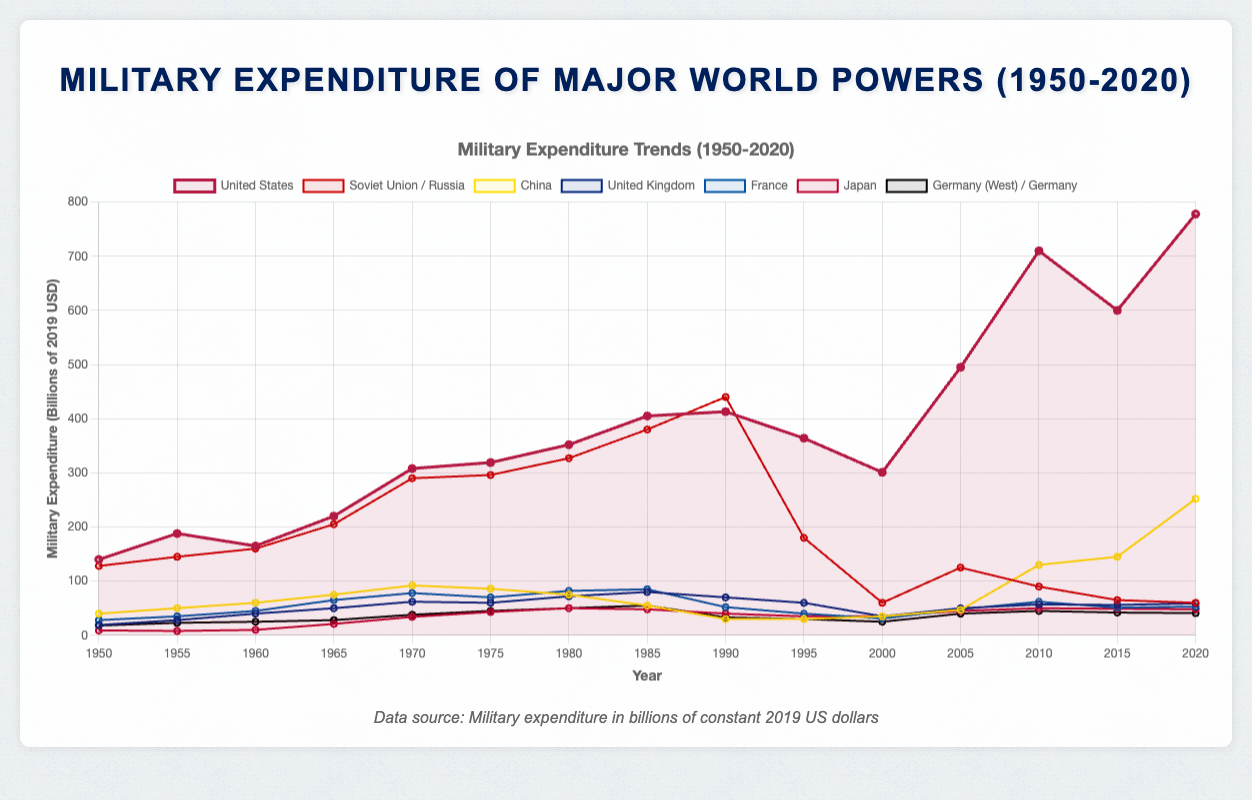Which country had the highest military expenditure in 2020? In 2020, looking at the topmost line in the plot, the military expenditure of the United States was the highest.
Answer: United States During which decade did China's military expenditure start to increase significantly? By observing the plot, the military expenditure of China begins to rise noticeably around the 2000s, particularly after 2005.
Answer: 2000s Compare the military expenditure of the Soviet Union/Russia and the United States in 1990. Which was higher? In 1990, the data shows that the United States had a military expenditure of 413 billion while the Soviet Union/Russia had 440 billion.
Answer: Soviet Union/Russia What was the approximate difference in military expenditure between the United States and China in 2010? In 2010, the military expenditure of the United States was 710 billion, and China's was 130 billion. The difference is 710 - 130 = 580 billion.
Answer: 580 billion During which year did the United States' military expenditure exceed 700 billion for the first time? By examining the data provided, the United States’ military expenditure first exceeded 700 billion in 2010.
Answer: 2010 Which country had the lowest military expenditure in 1950, and what was that value? In 1950, Japan had the lowest military expenditure among the listed countries, at 9 billion.
Answer: Japan, 9 billion Was there any decade in which Germany's military expenditure constantly increased or remained stable? Analyzing the plot for Germany, there was no decade where the expenditure consistently increased or remained stable without fluctuation.
Answer: No How did the military expenditure of the United Kingdom change between 2000 and 2010? Between 2000 and 2010, the UK's military expenditure went from 35 billion in 2000 to 50 billion in 2010, showing an overall increase.
Answer: Increased Identify the decade in which France had the highest military expenditure. According to the plot, France had its highest military expenditure in the 1980s, reaching 85 billion.
Answer: 1980s 